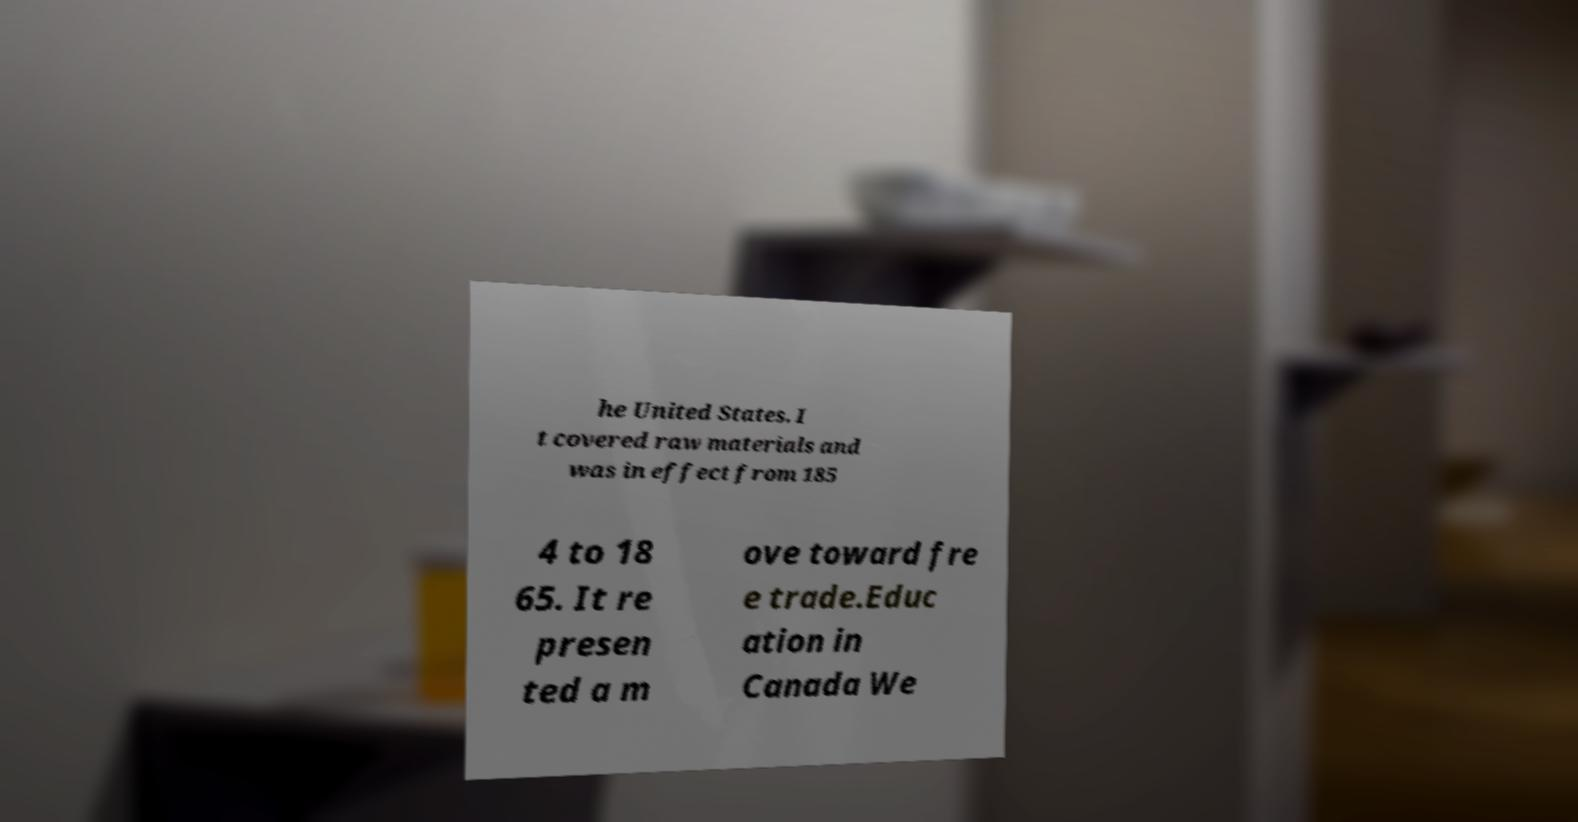Please identify and transcribe the text found in this image. he United States. I t covered raw materials and was in effect from 185 4 to 18 65. It re presen ted a m ove toward fre e trade.Educ ation in Canada We 